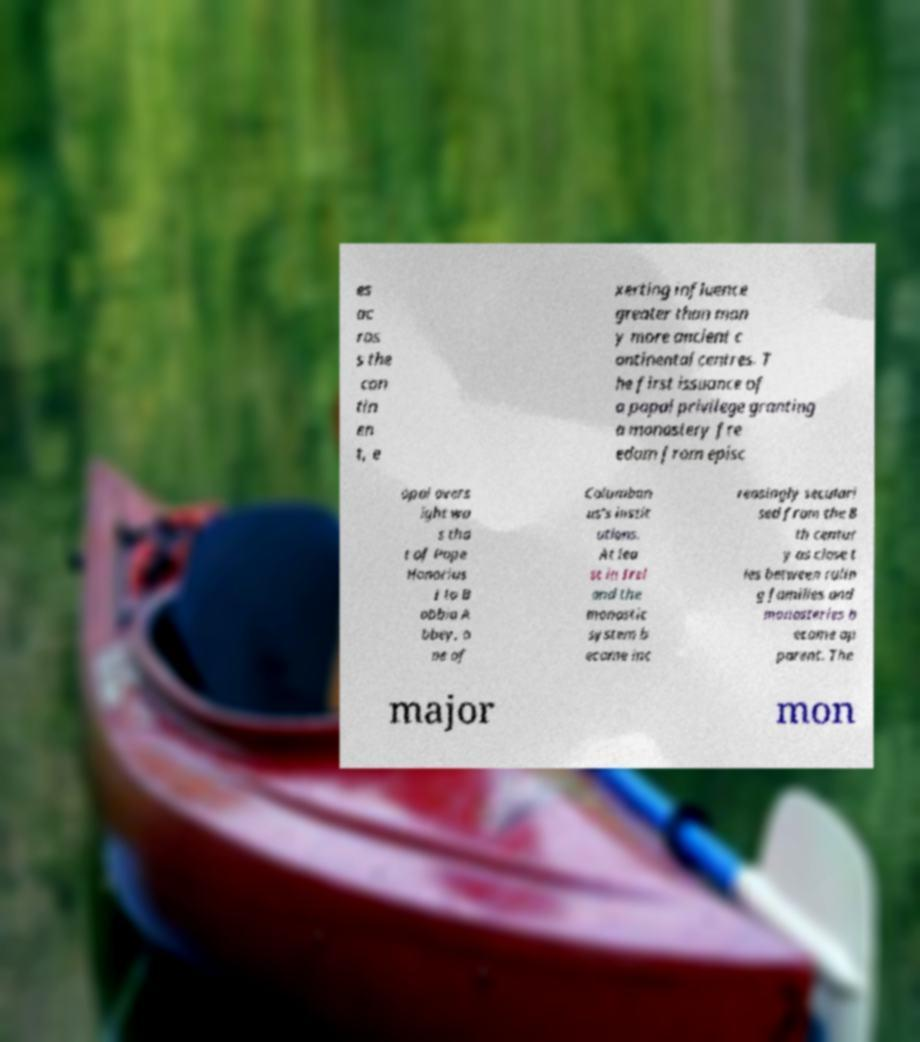What messages or text are displayed in this image? I need them in a readable, typed format. es ac ros s the con tin en t, e xerting influence greater than man y more ancient c ontinental centres. T he first issuance of a papal privilege granting a monastery fre edom from episc opal overs ight wa s tha t of Pope Honorius I to B obbio A bbey, o ne of Columban us's instit utions. At lea st in Irel and the monastic system b ecame inc reasingly seculari sed from the 8 th centur y as close t ies between rulin g families and monasteries b ecame ap parent. The major mon 